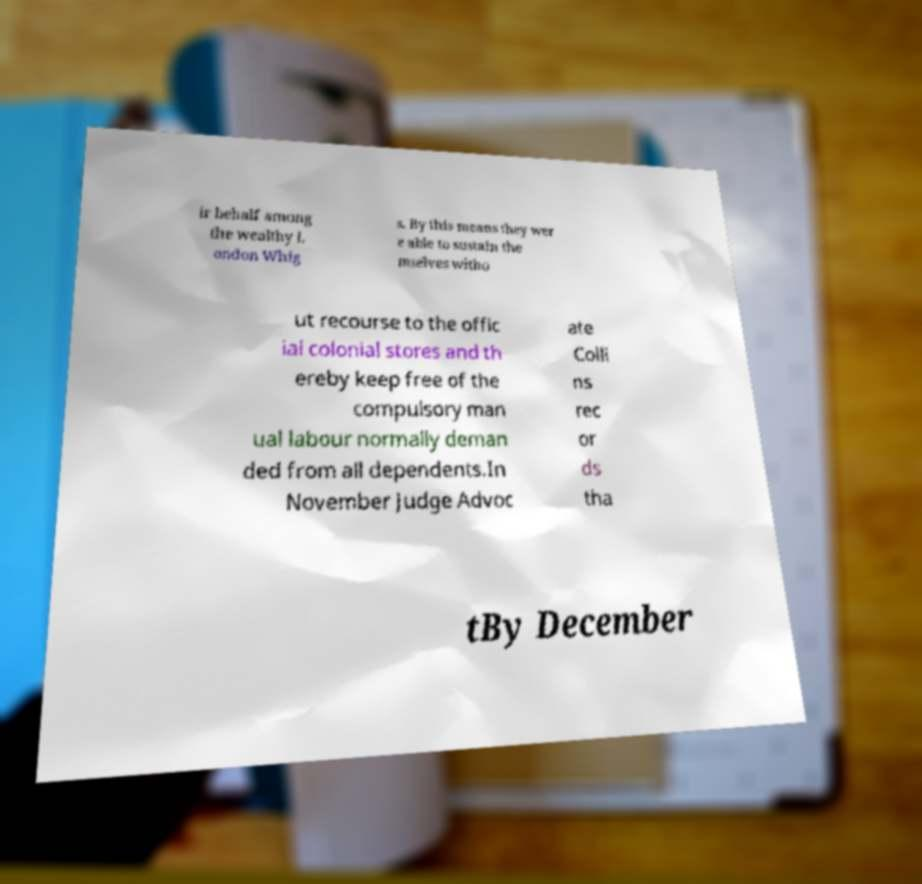Please read and relay the text visible in this image. What does it say? ir behalf among the wealthy L ondon Whig s. By this means they wer e able to sustain the mselves witho ut recourse to the offic ial colonial stores and th ereby keep free of the compulsory man ual labour normally deman ded from all dependents.In November Judge Advoc ate Colli ns rec or ds tha tBy December 